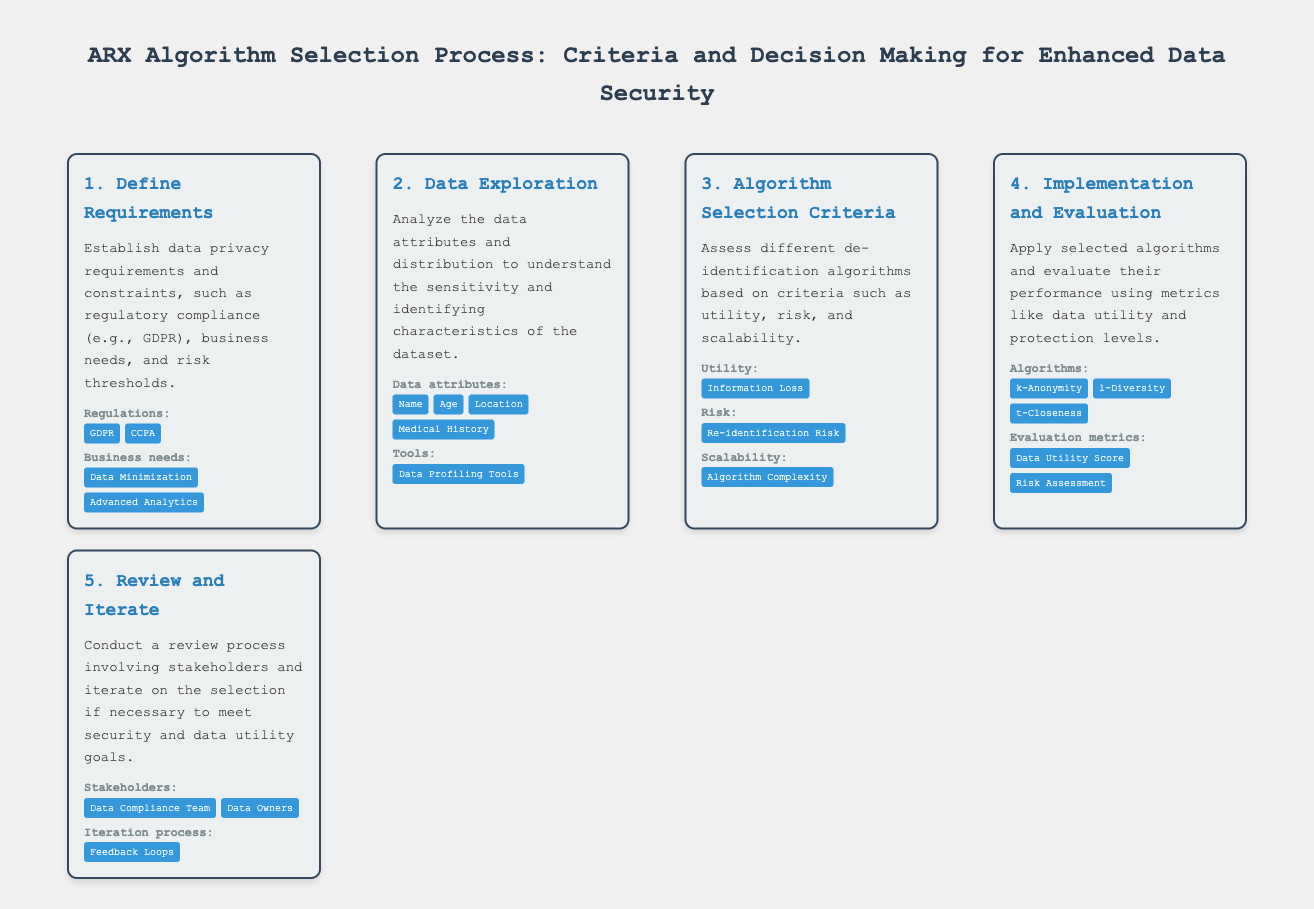what is the first step in the ARX algorithm selection process? The first step mentioned is to "Define Requirements."
Answer: Define Requirements which regulations are associated with the requirements? The document lists "GDPR" and "CCPA" as associated regulations.
Answer: GDPR, CCPA what is the main criteria used for algorithm selection? The main criteria assessed for algorithm selection are "utility, risk, and scalability."
Answer: utility, risk, and scalability name one algorithm mentioned in the implementation and evaluation step. One algorithm listed is "k-Anonymity."
Answer: k-Anonymity who are the stakeholders involved in the review process? The stakeholders mentioned are "Data Compliance Team" and "Data Owners."
Answer: Data Compliance Team, Data Owners what tool is suggested for data exploration? The document mentions the use of "Data Profiling Tools" for data exploration.
Answer: Data Profiling Tools what is the definition of utility in the context of algorithm selection? The document defines utility in terms of "Information Loss."
Answer: Information Loss what is the purpose of the review and iterate step? The purpose is to "conduct a review process involving stakeholders and iterate on the selection if necessary."
Answer: conduct a review process involving stakeholders and iterate on the selection if necessary 